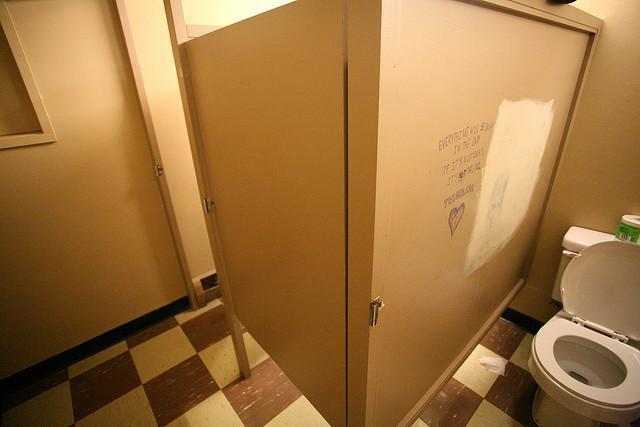How many toilets are in this bathroom?
Give a very brief answer. 2. 